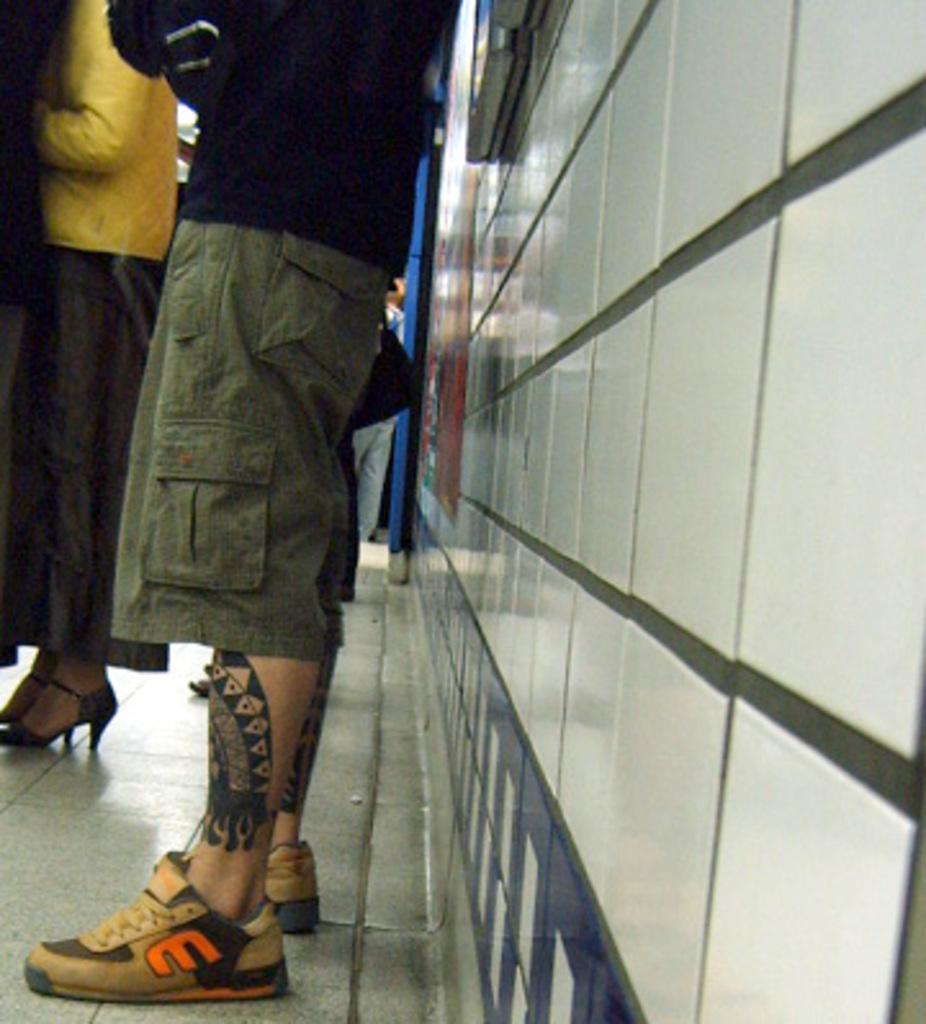Could you give a brief overview of what you see in this image? In this picture I can see people standing on the surface. I can see a person wearing shoes on the right side. I can see the tattoo on his leg. I can see a woman wearing heels on the left side. I can see the wall on the right side. 